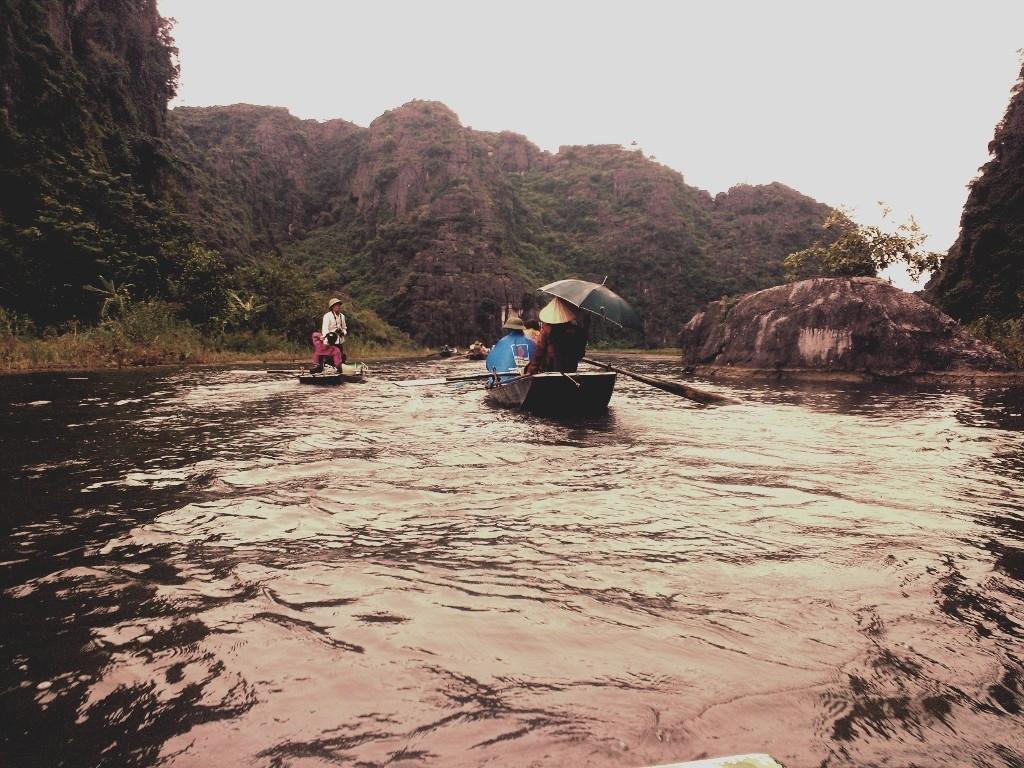Please provide a concise description of this image. In this image we can see persons on boat sailing on the water. In the background we can see hills, trees and sky. 